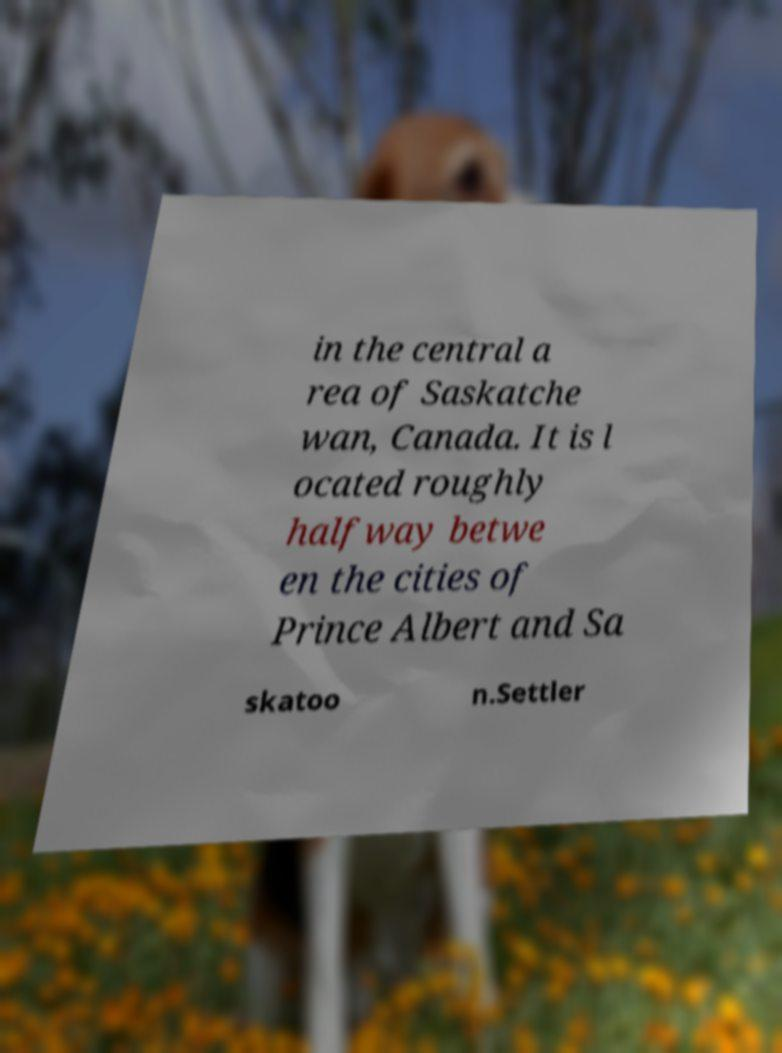What messages or text are displayed in this image? I need them in a readable, typed format. in the central a rea of Saskatche wan, Canada. It is l ocated roughly halfway betwe en the cities of Prince Albert and Sa skatoo n.Settler 